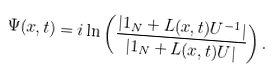Convert formula to latex. <formula><loc_0><loc_0><loc_500><loc_500>\Psi ( x , t ) = i \ln \left ( \frac { | { 1 } _ { N } + L ( x , t ) U ^ { - 1 } | } { | { 1 } _ { N } + L ( x , t ) U | } \right ) .</formula> 